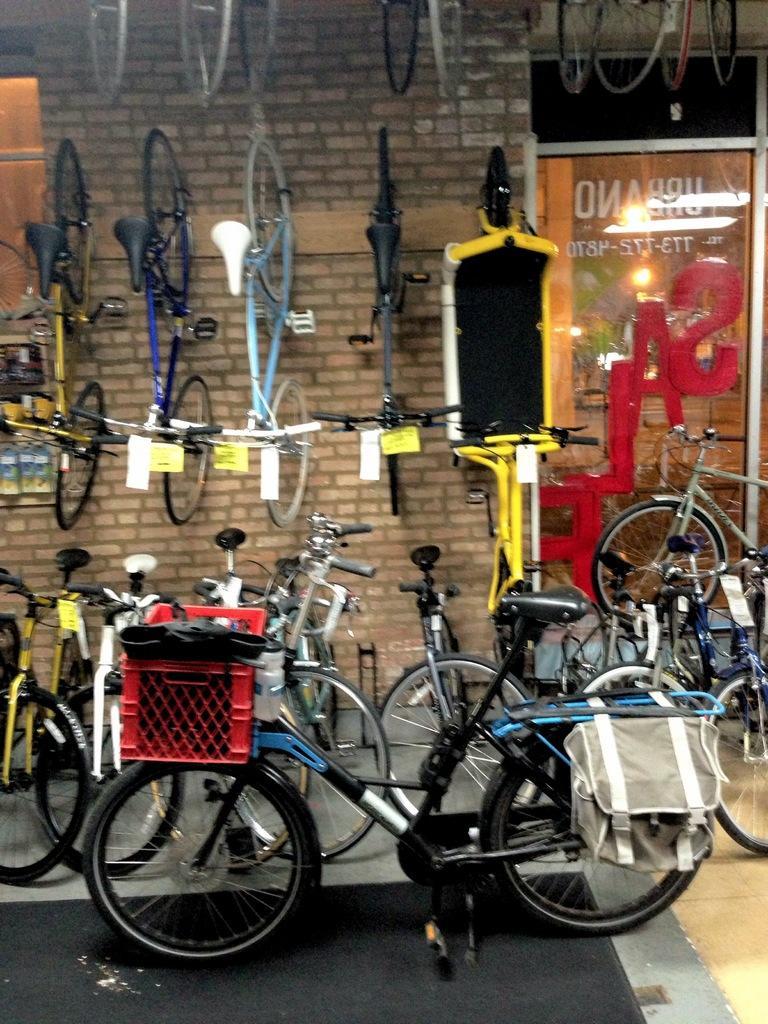Can you describe this image briefly? In this picture there are bicycles. In the foreground there is a bag and basket on the bicycle. At the back there is a board and there is a reflection of light on the board. 